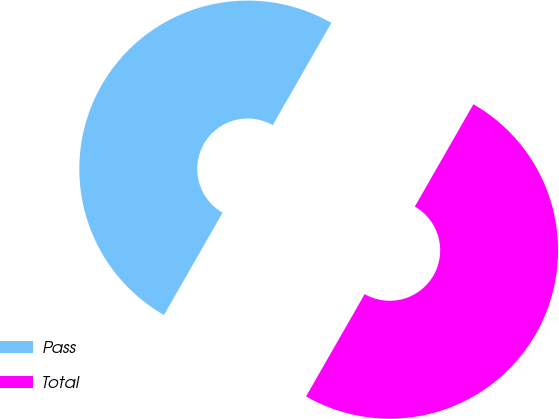<chart> <loc_0><loc_0><loc_500><loc_500><pie_chart><fcel>Pass<fcel>Total<nl><fcel>50.0%<fcel>50.0%<nl></chart> 